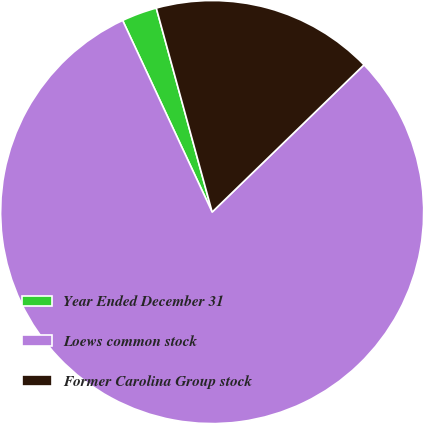Convert chart to OTSL. <chart><loc_0><loc_0><loc_500><loc_500><pie_chart><fcel>Year Ended December 31<fcel>Loews common stock<fcel>Former Carolina Group stock<nl><fcel>2.7%<fcel>80.3%<fcel>17.0%<nl></chart> 